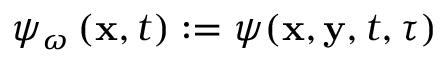<formula> <loc_0><loc_0><loc_500><loc_500>\psi _ { \omega } \left ( x , t \right ) \colon = \psi ( x , y , t , \tau )</formula> 